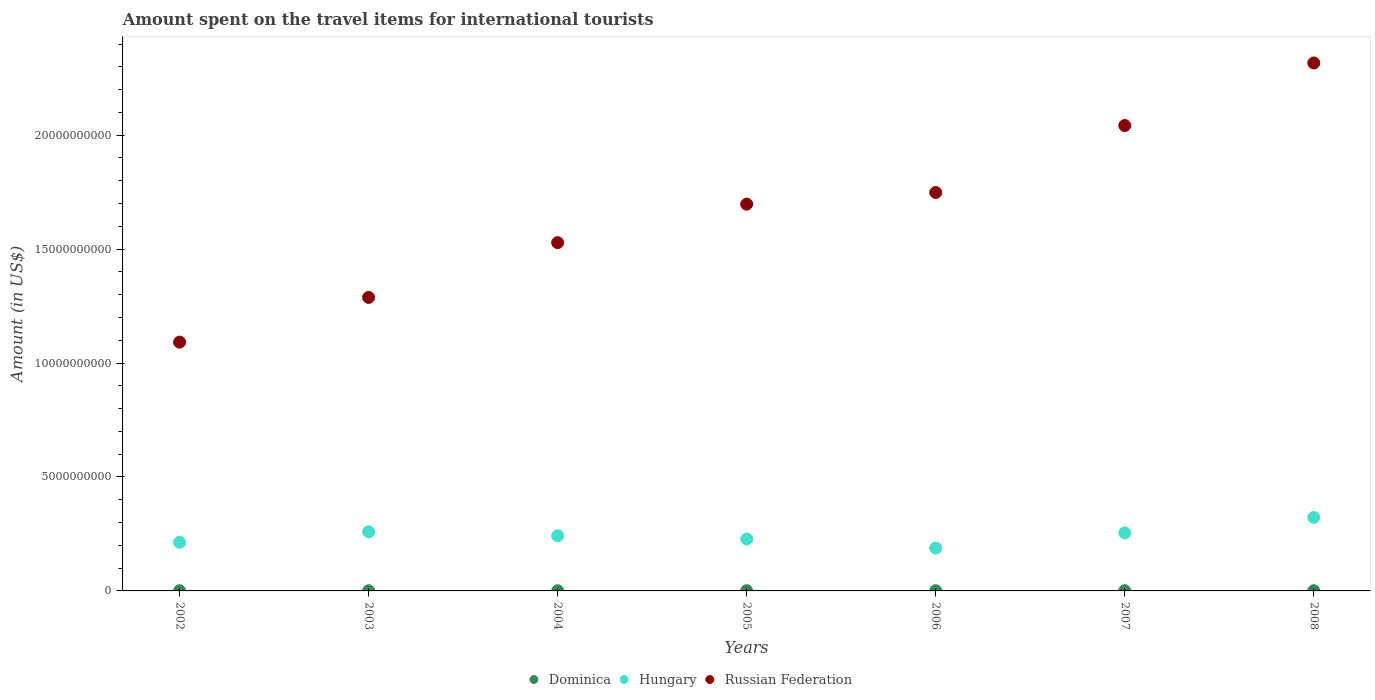Is the number of dotlines equal to the number of legend labels?
Provide a succinct answer. Yes. What is the amount spent on the travel items for international tourists in Hungary in 2006?
Make the answer very short. 1.88e+09. Across all years, what is the maximum amount spent on the travel items for international tourists in Russian Federation?
Give a very brief answer. 2.32e+1. Across all years, what is the minimum amount spent on the travel items for international tourists in Russian Federation?
Give a very brief answer. 1.09e+1. In which year was the amount spent on the travel items for international tourists in Russian Federation maximum?
Ensure brevity in your answer.  2008. What is the total amount spent on the travel items for international tourists in Russian Federation in the graph?
Your answer should be very brief. 1.17e+11. What is the difference between the amount spent on the travel items for international tourists in Russian Federation in 2003 and that in 2008?
Your response must be concise. -1.03e+1. What is the difference between the amount spent on the travel items for international tourists in Russian Federation in 2007 and the amount spent on the travel items for international tourists in Dominica in 2008?
Provide a succinct answer. 2.04e+1. What is the average amount spent on the travel items for international tourists in Dominica per year?
Give a very brief answer. 9.86e+06. In the year 2002, what is the difference between the amount spent on the travel items for international tourists in Hungary and amount spent on the travel items for international tourists in Russian Federation?
Give a very brief answer. -8.78e+09. What is the ratio of the amount spent on the travel items for international tourists in Russian Federation in 2002 to that in 2007?
Give a very brief answer. 0.53. Is the difference between the amount spent on the travel items for international tourists in Hungary in 2003 and 2005 greater than the difference between the amount spent on the travel items for international tourists in Russian Federation in 2003 and 2005?
Your answer should be compact. Yes. What is the difference between the highest and the second highest amount spent on the travel items for international tourists in Russian Federation?
Offer a very short reply. 2.74e+09. What is the difference between the highest and the lowest amount spent on the travel items for international tourists in Russian Federation?
Your answer should be compact. 1.23e+1. In how many years, is the amount spent on the travel items for international tourists in Russian Federation greater than the average amount spent on the travel items for international tourists in Russian Federation taken over all years?
Provide a short and direct response. 4. Is it the case that in every year, the sum of the amount spent on the travel items for international tourists in Russian Federation and amount spent on the travel items for international tourists in Dominica  is greater than the amount spent on the travel items for international tourists in Hungary?
Give a very brief answer. Yes. Is the amount spent on the travel items for international tourists in Hungary strictly greater than the amount spent on the travel items for international tourists in Dominica over the years?
Keep it short and to the point. Yes. How many dotlines are there?
Ensure brevity in your answer.  3. How many years are there in the graph?
Your answer should be compact. 7. Are the values on the major ticks of Y-axis written in scientific E-notation?
Your answer should be very brief. No. What is the title of the graph?
Provide a succinct answer. Amount spent on the travel items for international tourists. What is the label or title of the X-axis?
Provide a succinct answer. Years. What is the Amount (in US$) of Dominica in 2002?
Offer a terse response. 9.00e+06. What is the Amount (in US$) in Hungary in 2002?
Offer a very short reply. 2.13e+09. What is the Amount (in US$) in Russian Federation in 2002?
Give a very brief answer. 1.09e+1. What is the Amount (in US$) in Dominica in 2003?
Provide a succinct answer. 9.00e+06. What is the Amount (in US$) of Hungary in 2003?
Offer a very short reply. 2.59e+09. What is the Amount (in US$) in Russian Federation in 2003?
Offer a very short reply. 1.29e+1. What is the Amount (in US$) of Dominica in 2004?
Ensure brevity in your answer.  9.00e+06. What is the Amount (in US$) in Hungary in 2004?
Provide a succinct answer. 2.42e+09. What is the Amount (in US$) of Russian Federation in 2004?
Make the answer very short. 1.53e+1. What is the Amount (in US$) in Dominica in 2005?
Give a very brief answer. 1.00e+07. What is the Amount (in US$) of Hungary in 2005?
Provide a succinct answer. 2.28e+09. What is the Amount (in US$) in Russian Federation in 2005?
Your answer should be compact. 1.70e+1. What is the Amount (in US$) in Hungary in 2006?
Give a very brief answer. 1.88e+09. What is the Amount (in US$) of Russian Federation in 2006?
Offer a terse response. 1.75e+1. What is the Amount (in US$) in Dominica in 2007?
Keep it short and to the point. 1.10e+07. What is the Amount (in US$) in Hungary in 2007?
Make the answer very short. 2.55e+09. What is the Amount (in US$) of Russian Federation in 2007?
Make the answer very short. 2.04e+1. What is the Amount (in US$) in Dominica in 2008?
Provide a succinct answer. 1.10e+07. What is the Amount (in US$) in Hungary in 2008?
Offer a terse response. 3.22e+09. What is the Amount (in US$) in Russian Federation in 2008?
Ensure brevity in your answer.  2.32e+1. Across all years, what is the maximum Amount (in US$) of Dominica?
Provide a succinct answer. 1.10e+07. Across all years, what is the maximum Amount (in US$) in Hungary?
Provide a succinct answer. 3.22e+09. Across all years, what is the maximum Amount (in US$) in Russian Federation?
Provide a succinct answer. 2.32e+1. Across all years, what is the minimum Amount (in US$) of Dominica?
Your answer should be compact. 9.00e+06. Across all years, what is the minimum Amount (in US$) in Hungary?
Give a very brief answer. 1.88e+09. Across all years, what is the minimum Amount (in US$) of Russian Federation?
Offer a terse response. 1.09e+1. What is the total Amount (in US$) of Dominica in the graph?
Your answer should be very brief. 6.90e+07. What is the total Amount (in US$) of Hungary in the graph?
Offer a terse response. 1.71e+1. What is the total Amount (in US$) of Russian Federation in the graph?
Make the answer very short. 1.17e+11. What is the difference between the Amount (in US$) in Dominica in 2002 and that in 2003?
Your answer should be very brief. 0. What is the difference between the Amount (in US$) of Hungary in 2002 and that in 2003?
Your answer should be compact. -4.61e+08. What is the difference between the Amount (in US$) in Russian Federation in 2002 and that in 2003?
Your response must be concise. -1.96e+09. What is the difference between the Amount (in US$) of Dominica in 2002 and that in 2004?
Offer a very short reply. 0. What is the difference between the Amount (in US$) in Hungary in 2002 and that in 2004?
Give a very brief answer. -2.88e+08. What is the difference between the Amount (in US$) in Russian Federation in 2002 and that in 2004?
Your response must be concise. -4.37e+09. What is the difference between the Amount (in US$) of Dominica in 2002 and that in 2005?
Ensure brevity in your answer.  -1.00e+06. What is the difference between the Amount (in US$) in Hungary in 2002 and that in 2005?
Ensure brevity in your answer.  -1.44e+08. What is the difference between the Amount (in US$) in Russian Federation in 2002 and that in 2005?
Ensure brevity in your answer.  -6.05e+09. What is the difference between the Amount (in US$) in Hungary in 2002 and that in 2006?
Your response must be concise. 2.54e+08. What is the difference between the Amount (in US$) in Russian Federation in 2002 and that in 2006?
Your answer should be very brief. -6.57e+09. What is the difference between the Amount (in US$) of Dominica in 2002 and that in 2007?
Provide a short and direct response. -2.00e+06. What is the difference between the Amount (in US$) of Hungary in 2002 and that in 2007?
Your answer should be compact. -4.13e+08. What is the difference between the Amount (in US$) in Russian Federation in 2002 and that in 2007?
Your answer should be compact. -9.51e+09. What is the difference between the Amount (in US$) in Dominica in 2002 and that in 2008?
Ensure brevity in your answer.  -2.00e+06. What is the difference between the Amount (in US$) in Hungary in 2002 and that in 2008?
Ensure brevity in your answer.  -1.09e+09. What is the difference between the Amount (in US$) in Russian Federation in 2002 and that in 2008?
Provide a short and direct response. -1.23e+1. What is the difference between the Amount (in US$) of Dominica in 2003 and that in 2004?
Offer a terse response. 0. What is the difference between the Amount (in US$) in Hungary in 2003 and that in 2004?
Your answer should be compact. 1.73e+08. What is the difference between the Amount (in US$) of Russian Federation in 2003 and that in 2004?
Offer a terse response. -2.40e+09. What is the difference between the Amount (in US$) of Dominica in 2003 and that in 2005?
Keep it short and to the point. -1.00e+06. What is the difference between the Amount (in US$) of Hungary in 2003 and that in 2005?
Offer a terse response. 3.17e+08. What is the difference between the Amount (in US$) in Russian Federation in 2003 and that in 2005?
Ensure brevity in your answer.  -4.09e+09. What is the difference between the Amount (in US$) of Dominica in 2003 and that in 2006?
Offer a very short reply. -1.00e+06. What is the difference between the Amount (in US$) of Hungary in 2003 and that in 2006?
Your response must be concise. 7.15e+08. What is the difference between the Amount (in US$) in Russian Federation in 2003 and that in 2006?
Your response must be concise. -4.60e+09. What is the difference between the Amount (in US$) of Dominica in 2003 and that in 2007?
Offer a terse response. -2.00e+06. What is the difference between the Amount (in US$) in Hungary in 2003 and that in 2007?
Offer a terse response. 4.80e+07. What is the difference between the Amount (in US$) in Russian Federation in 2003 and that in 2007?
Your response must be concise. -7.54e+09. What is the difference between the Amount (in US$) in Hungary in 2003 and that in 2008?
Offer a terse response. -6.31e+08. What is the difference between the Amount (in US$) of Russian Federation in 2003 and that in 2008?
Your answer should be compact. -1.03e+1. What is the difference between the Amount (in US$) of Dominica in 2004 and that in 2005?
Your answer should be compact. -1.00e+06. What is the difference between the Amount (in US$) in Hungary in 2004 and that in 2005?
Your answer should be very brief. 1.44e+08. What is the difference between the Amount (in US$) of Russian Federation in 2004 and that in 2005?
Keep it short and to the point. -1.69e+09. What is the difference between the Amount (in US$) of Hungary in 2004 and that in 2006?
Give a very brief answer. 5.42e+08. What is the difference between the Amount (in US$) of Russian Federation in 2004 and that in 2006?
Your response must be concise. -2.20e+09. What is the difference between the Amount (in US$) in Hungary in 2004 and that in 2007?
Give a very brief answer. -1.25e+08. What is the difference between the Amount (in US$) of Russian Federation in 2004 and that in 2007?
Offer a terse response. -5.14e+09. What is the difference between the Amount (in US$) in Dominica in 2004 and that in 2008?
Make the answer very short. -2.00e+06. What is the difference between the Amount (in US$) of Hungary in 2004 and that in 2008?
Ensure brevity in your answer.  -8.04e+08. What is the difference between the Amount (in US$) in Russian Federation in 2004 and that in 2008?
Offer a terse response. -7.88e+09. What is the difference between the Amount (in US$) of Dominica in 2005 and that in 2006?
Offer a terse response. 0. What is the difference between the Amount (in US$) in Hungary in 2005 and that in 2006?
Keep it short and to the point. 3.98e+08. What is the difference between the Amount (in US$) in Russian Federation in 2005 and that in 2006?
Your response must be concise. -5.12e+08. What is the difference between the Amount (in US$) in Dominica in 2005 and that in 2007?
Your answer should be compact. -1.00e+06. What is the difference between the Amount (in US$) in Hungary in 2005 and that in 2007?
Your answer should be compact. -2.69e+08. What is the difference between the Amount (in US$) in Russian Federation in 2005 and that in 2007?
Give a very brief answer. -3.45e+09. What is the difference between the Amount (in US$) in Hungary in 2005 and that in 2008?
Your answer should be compact. -9.48e+08. What is the difference between the Amount (in US$) of Russian Federation in 2005 and that in 2008?
Your response must be concise. -6.20e+09. What is the difference between the Amount (in US$) of Dominica in 2006 and that in 2007?
Give a very brief answer. -1.00e+06. What is the difference between the Amount (in US$) of Hungary in 2006 and that in 2007?
Provide a succinct answer. -6.67e+08. What is the difference between the Amount (in US$) of Russian Federation in 2006 and that in 2007?
Offer a terse response. -2.94e+09. What is the difference between the Amount (in US$) of Dominica in 2006 and that in 2008?
Your answer should be compact. -1.00e+06. What is the difference between the Amount (in US$) of Hungary in 2006 and that in 2008?
Offer a very short reply. -1.35e+09. What is the difference between the Amount (in US$) in Russian Federation in 2006 and that in 2008?
Give a very brief answer. -5.68e+09. What is the difference between the Amount (in US$) of Dominica in 2007 and that in 2008?
Give a very brief answer. 0. What is the difference between the Amount (in US$) of Hungary in 2007 and that in 2008?
Your answer should be very brief. -6.79e+08. What is the difference between the Amount (in US$) in Russian Federation in 2007 and that in 2008?
Ensure brevity in your answer.  -2.74e+09. What is the difference between the Amount (in US$) of Dominica in 2002 and the Amount (in US$) of Hungary in 2003?
Give a very brief answer. -2.58e+09. What is the difference between the Amount (in US$) of Dominica in 2002 and the Amount (in US$) of Russian Federation in 2003?
Make the answer very short. -1.29e+1. What is the difference between the Amount (in US$) of Hungary in 2002 and the Amount (in US$) of Russian Federation in 2003?
Keep it short and to the point. -1.07e+1. What is the difference between the Amount (in US$) of Dominica in 2002 and the Amount (in US$) of Hungary in 2004?
Your response must be concise. -2.41e+09. What is the difference between the Amount (in US$) of Dominica in 2002 and the Amount (in US$) of Russian Federation in 2004?
Your answer should be very brief. -1.53e+1. What is the difference between the Amount (in US$) in Hungary in 2002 and the Amount (in US$) in Russian Federation in 2004?
Your response must be concise. -1.32e+1. What is the difference between the Amount (in US$) of Dominica in 2002 and the Amount (in US$) of Hungary in 2005?
Provide a succinct answer. -2.27e+09. What is the difference between the Amount (in US$) in Dominica in 2002 and the Amount (in US$) in Russian Federation in 2005?
Give a very brief answer. -1.70e+1. What is the difference between the Amount (in US$) in Hungary in 2002 and the Amount (in US$) in Russian Federation in 2005?
Your answer should be compact. -1.48e+1. What is the difference between the Amount (in US$) in Dominica in 2002 and the Amount (in US$) in Hungary in 2006?
Keep it short and to the point. -1.87e+09. What is the difference between the Amount (in US$) in Dominica in 2002 and the Amount (in US$) in Russian Federation in 2006?
Your answer should be compact. -1.75e+1. What is the difference between the Amount (in US$) in Hungary in 2002 and the Amount (in US$) in Russian Federation in 2006?
Your response must be concise. -1.54e+1. What is the difference between the Amount (in US$) of Dominica in 2002 and the Amount (in US$) of Hungary in 2007?
Provide a short and direct response. -2.54e+09. What is the difference between the Amount (in US$) of Dominica in 2002 and the Amount (in US$) of Russian Federation in 2007?
Provide a short and direct response. -2.04e+1. What is the difference between the Amount (in US$) in Hungary in 2002 and the Amount (in US$) in Russian Federation in 2007?
Provide a short and direct response. -1.83e+1. What is the difference between the Amount (in US$) in Dominica in 2002 and the Amount (in US$) in Hungary in 2008?
Keep it short and to the point. -3.22e+09. What is the difference between the Amount (in US$) of Dominica in 2002 and the Amount (in US$) of Russian Federation in 2008?
Give a very brief answer. -2.32e+1. What is the difference between the Amount (in US$) in Hungary in 2002 and the Amount (in US$) in Russian Federation in 2008?
Keep it short and to the point. -2.10e+1. What is the difference between the Amount (in US$) in Dominica in 2003 and the Amount (in US$) in Hungary in 2004?
Your answer should be compact. -2.41e+09. What is the difference between the Amount (in US$) in Dominica in 2003 and the Amount (in US$) in Russian Federation in 2004?
Your answer should be very brief. -1.53e+1. What is the difference between the Amount (in US$) of Hungary in 2003 and the Amount (in US$) of Russian Federation in 2004?
Your answer should be compact. -1.27e+1. What is the difference between the Amount (in US$) of Dominica in 2003 and the Amount (in US$) of Hungary in 2005?
Your response must be concise. -2.27e+09. What is the difference between the Amount (in US$) of Dominica in 2003 and the Amount (in US$) of Russian Federation in 2005?
Provide a succinct answer. -1.70e+1. What is the difference between the Amount (in US$) of Hungary in 2003 and the Amount (in US$) of Russian Federation in 2005?
Give a very brief answer. -1.44e+1. What is the difference between the Amount (in US$) of Dominica in 2003 and the Amount (in US$) of Hungary in 2006?
Provide a short and direct response. -1.87e+09. What is the difference between the Amount (in US$) of Dominica in 2003 and the Amount (in US$) of Russian Federation in 2006?
Give a very brief answer. -1.75e+1. What is the difference between the Amount (in US$) in Hungary in 2003 and the Amount (in US$) in Russian Federation in 2006?
Give a very brief answer. -1.49e+1. What is the difference between the Amount (in US$) of Dominica in 2003 and the Amount (in US$) of Hungary in 2007?
Ensure brevity in your answer.  -2.54e+09. What is the difference between the Amount (in US$) in Dominica in 2003 and the Amount (in US$) in Russian Federation in 2007?
Give a very brief answer. -2.04e+1. What is the difference between the Amount (in US$) of Hungary in 2003 and the Amount (in US$) of Russian Federation in 2007?
Provide a succinct answer. -1.78e+1. What is the difference between the Amount (in US$) of Dominica in 2003 and the Amount (in US$) of Hungary in 2008?
Your answer should be compact. -3.22e+09. What is the difference between the Amount (in US$) in Dominica in 2003 and the Amount (in US$) in Russian Federation in 2008?
Keep it short and to the point. -2.32e+1. What is the difference between the Amount (in US$) of Hungary in 2003 and the Amount (in US$) of Russian Federation in 2008?
Ensure brevity in your answer.  -2.06e+1. What is the difference between the Amount (in US$) in Dominica in 2004 and the Amount (in US$) in Hungary in 2005?
Offer a terse response. -2.27e+09. What is the difference between the Amount (in US$) of Dominica in 2004 and the Amount (in US$) of Russian Federation in 2005?
Your answer should be very brief. -1.70e+1. What is the difference between the Amount (in US$) of Hungary in 2004 and the Amount (in US$) of Russian Federation in 2005?
Provide a short and direct response. -1.46e+1. What is the difference between the Amount (in US$) in Dominica in 2004 and the Amount (in US$) in Hungary in 2006?
Provide a short and direct response. -1.87e+09. What is the difference between the Amount (in US$) of Dominica in 2004 and the Amount (in US$) of Russian Federation in 2006?
Offer a very short reply. -1.75e+1. What is the difference between the Amount (in US$) of Hungary in 2004 and the Amount (in US$) of Russian Federation in 2006?
Offer a very short reply. -1.51e+1. What is the difference between the Amount (in US$) in Dominica in 2004 and the Amount (in US$) in Hungary in 2007?
Offer a terse response. -2.54e+09. What is the difference between the Amount (in US$) of Dominica in 2004 and the Amount (in US$) of Russian Federation in 2007?
Your answer should be compact. -2.04e+1. What is the difference between the Amount (in US$) of Hungary in 2004 and the Amount (in US$) of Russian Federation in 2007?
Your answer should be very brief. -1.80e+1. What is the difference between the Amount (in US$) of Dominica in 2004 and the Amount (in US$) of Hungary in 2008?
Your answer should be compact. -3.22e+09. What is the difference between the Amount (in US$) in Dominica in 2004 and the Amount (in US$) in Russian Federation in 2008?
Ensure brevity in your answer.  -2.32e+1. What is the difference between the Amount (in US$) in Hungary in 2004 and the Amount (in US$) in Russian Federation in 2008?
Ensure brevity in your answer.  -2.07e+1. What is the difference between the Amount (in US$) in Dominica in 2005 and the Amount (in US$) in Hungary in 2006?
Your answer should be compact. -1.87e+09. What is the difference between the Amount (in US$) of Dominica in 2005 and the Amount (in US$) of Russian Federation in 2006?
Your answer should be compact. -1.75e+1. What is the difference between the Amount (in US$) in Hungary in 2005 and the Amount (in US$) in Russian Federation in 2006?
Your answer should be compact. -1.52e+1. What is the difference between the Amount (in US$) of Dominica in 2005 and the Amount (in US$) of Hungary in 2007?
Your response must be concise. -2.54e+09. What is the difference between the Amount (in US$) of Dominica in 2005 and the Amount (in US$) of Russian Federation in 2007?
Keep it short and to the point. -2.04e+1. What is the difference between the Amount (in US$) of Hungary in 2005 and the Amount (in US$) of Russian Federation in 2007?
Provide a succinct answer. -1.81e+1. What is the difference between the Amount (in US$) of Dominica in 2005 and the Amount (in US$) of Hungary in 2008?
Offer a very short reply. -3.22e+09. What is the difference between the Amount (in US$) of Dominica in 2005 and the Amount (in US$) of Russian Federation in 2008?
Ensure brevity in your answer.  -2.32e+1. What is the difference between the Amount (in US$) in Hungary in 2005 and the Amount (in US$) in Russian Federation in 2008?
Give a very brief answer. -2.09e+1. What is the difference between the Amount (in US$) in Dominica in 2006 and the Amount (in US$) in Hungary in 2007?
Your response must be concise. -2.54e+09. What is the difference between the Amount (in US$) in Dominica in 2006 and the Amount (in US$) in Russian Federation in 2007?
Your response must be concise. -2.04e+1. What is the difference between the Amount (in US$) in Hungary in 2006 and the Amount (in US$) in Russian Federation in 2007?
Your answer should be compact. -1.85e+1. What is the difference between the Amount (in US$) in Dominica in 2006 and the Amount (in US$) in Hungary in 2008?
Offer a terse response. -3.22e+09. What is the difference between the Amount (in US$) of Dominica in 2006 and the Amount (in US$) of Russian Federation in 2008?
Your response must be concise. -2.32e+1. What is the difference between the Amount (in US$) in Hungary in 2006 and the Amount (in US$) in Russian Federation in 2008?
Your answer should be very brief. -2.13e+1. What is the difference between the Amount (in US$) in Dominica in 2007 and the Amount (in US$) in Hungary in 2008?
Provide a short and direct response. -3.21e+09. What is the difference between the Amount (in US$) in Dominica in 2007 and the Amount (in US$) in Russian Federation in 2008?
Provide a short and direct response. -2.32e+1. What is the difference between the Amount (in US$) in Hungary in 2007 and the Amount (in US$) in Russian Federation in 2008?
Offer a very short reply. -2.06e+1. What is the average Amount (in US$) in Dominica per year?
Make the answer very short. 9.86e+06. What is the average Amount (in US$) in Hungary per year?
Ensure brevity in your answer.  2.44e+09. What is the average Amount (in US$) of Russian Federation per year?
Ensure brevity in your answer.  1.67e+1. In the year 2002, what is the difference between the Amount (in US$) of Dominica and Amount (in US$) of Hungary?
Your answer should be compact. -2.12e+09. In the year 2002, what is the difference between the Amount (in US$) of Dominica and Amount (in US$) of Russian Federation?
Your response must be concise. -1.09e+1. In the year 2002, what is the difference between the Amount (in US$) of Hungary and Amount (in US$) of Russian Federation?
Your response must be concise. -8.78e+09. In the year 2003, what is the difference between the Amount (in US$) of Dominica and Amount (in US$) of Hungary?
Your response must be concise. -2.58e+09. In the year 2003, what is the difference between the Amount (in US$) in Dominica and Amount (in US$) in Russian Federation?
Your answer should be very brief. -1.29e+1. In the year 2003, what is the difference between the Amount (in US$) of Hungary and Amount (in US$) of Russian Federation?
Provide a short and direct response. -1.03e+1. In the year 2004, what is the difference between the Amount (in US$) in Dominica and Amount (in US$) in Hungary?
Your response must be concise. -2.41e+09. In the year 2004, what is the difference between the Amount (in US$) of Dominica and Amount (in US$) of Russian Federation?
Give a very brief answer. -1.53e+1. In the year 2004, what is the difference between the Amount (in US$) in Hungary and Amount (in US$) in Russian Federation?
Make the answer very short. -1.29e+1. In the year 2005, what is the difference between the Amount (in US$) of Dominica and Amount (in US$) of Hungary?
Your answer should be very brief. -2.27e+09. In the year 2005, what is the difference between the Amount (in US$) in Dominica and Amount (in US$) in Russian Federation?
Ensure brevity in your answer.  -1.70e+1. In the year 2005, what is the difference between the Amount (in US$) in Hungary and Amount (in US$) in Russian Federation?
Your answer should be very brief. -1.47e+1. In the year 2006, what is the difference between the Amount (in US$) in Dominica and Amount (in US$) in Hungary?
Give a very brief answer. -1.87e+09. In the year 2006, what is the difference between the Amount (in US$) in Dominica and Amount (in US$) in Russian Federation?
Offer a very short reply. -1.75e+1. In the year 2006, what is the difference between the Amount (in US$) in Hungary and Amount (in US$) in Russian Federation?
Provide a succinct answer. -1.56e+1. In the year 2007, what is the difference between the Amount (in US$) in Dominica and Amount (in US$) in Hungary?
Provide a succinct answer. -2.54e+09. In the year 2007, what is the difference between the Amount (in US$) of Dominica and Amount (in US$) of Russian Federation?
Offer a very short reply. -2.04e+1. In the year 2007, what is the difference between the Amount (in US$) of Hungary and Amount (in US$) of Russian Federation?
Make the answer very short. -1.79e+1. In the year 2008, what is the difference between the Amount (in US$) in Dominica and Amount (in US$) in Hungary?
Your answer should be very brief. -3.21e+09. In the year 2008, what is the difference between the Amount (in US$) in Dominica and Amount (in US$) in Russian Federation?
Provide a succinct answer. -2.32e+1. In the year 2008, what is the difference between the Amount (in US$) in Hungary and Amount (in US$) in Russian Federation?
Ensure brevity in your answer.  -1.99e+1. What is the ratio of the Amount (in US$) of Dominica in 2002 to that in 2003?
Offer a very short reply. 1. What is the ratio of the Amount (in US$) in Hungary in 2002 to that in 2003?
Your answer should be very brief. 0.82. What is the ratio of the Amount (in US$) of Russian Federation in 2002 to that in 2003?
Offer a very short reply. 0.85. What is the ratio of the Amount (in US$) in Hungary in 2002 to that in 2004?
Ensure brevity in your answer.  0.88. What is the ratio of the Amount (in US$) of Russian Federation in 2002 to that in 2004?
Provide a succinct answer. 0.71. What is the ratio of the Amount (in US$) of Dominica in 2002 to that in 2005?
Provide a short and direct response. 0.9. What is the ratio of the Amount (in US$) in Hungary in 2002 to that in 2005?
Your response must be concise. 0.94. What is the ratio of the Amount (in US$) in Russian Federation in 2002 to that in 2005?
Provide a short and direct response. 0.64. What is the ratio of the Amount (in US$) of Hungary in 2002 to that in 2006?
Your answer should be very brief. 1.14. What is the ratio of the Amount (in US$) of Russian Federation in 2002 to that in 2006?
Offer a terse response. 0.62. What is the ratio of the Amount (in US$) in Dominica in 2002 to that in 2007?
Your response must be concise. 0.82. What is the ratio of the Amount (in US$) in Hungary in 2002 to that in 2007?
Offer a terse response. 0.84. What is the ratio of the Amount (in US$) in Russian Federation in 2002 to that in 2007?
Provide a short and direct response. 0.53. What is the ratio of the Amount (in US$) in Dominica in 2002 to that in 2008?
Make the answer very short. 0.82. What is the ratio of the Amount (in US$) in Hungary in 2002 to that in 2008?
Ensure brevity in your answer.  0.66. What is the ratio of the Amount (in US$) of Russian Federation in 2002 to that in 2008?
Offer a very short reply. 0.47. What is the ratio of the Amount (in US$) in Hungary in 2003 to that in 2004?
Your response must be concise. 1.07. What is the ratio of the Amount (in US$) of Russian Federation in 2003 to that in 2004?
Offer a very short reply. 0.84. What is the ratio of the Amount (in US$) of Hungary in 2003 to that in 2005?
Your response must be concise. 1.14. What is the ratio of the Amount (in US$) of Russian Federation in 2003 to that in 2005?
Ensure brevity in your answer.  0.76. What is the ratio of the Amount (in US$) in Dominica in 2003 to that in 2006?
Keep it short and to the point. 0.9. What is the ratio of the Amount (in US$) of Hungary in 2003 to that in 2006?
Offer a very short reply. 1.38. What is the ratio of the Amount (in US$) in Russian Federation in 2003 to that in 2006?
Provide a succinct answer. 0.74. What is the ratio of the Amount (in US$) in Dominica in 2003 to that in 2007?
Your response must be concise. 0.82. What is the ratio of the Amount (in US$) of Hungary in 2003 to that in 2007?
Offer a very short reply. 1.02. What is the ratio of the Amount (in US$) in Russian Federation in 2003 to that in 2007?
Make the answer very short. 0.63. What is the ratio of the Amount (in US$) in Dominica in 2003 to that in 2008?
Ensure brevity in your answer.  0.82. What is the ratio of the Amount (in US$) in Hungary in 2003 to that in 2008?
Offer a very short reply. 0.8. What is the ratio of the Amount (in US$) of Russian Federation in 2003 to that in 2008?
Give a very brief answer. 0.56. What is the ratio of the Amount (in US$) of Dominica in 2004 to that in 2005?
Ensure brevity in your answer.  0.9. What is the ratio of the Amount (in US$) in Hungary in 2004 to that in 2005?
Ensure brevity in your answer.  1.06. What is the ratio of the Amount (in US$) in Russian Federation in 2004 to that in 2005?
Keep it short and to the point. 0.9. What is the ratio of the Amount (in US$) in Hungary in 2004 to that in 2006?
Provide a short and direct response. 1.29. What is the ratio of the Amount (in US$) in Russian Federation in 2004 to that in 2006?
Make the answer very short. 0.87. What is the ratio of the Amount (in US$) in Dominica in 2004 to that in 2007?
Offer a very short reply. 0.82. What is the ratio of the Amount (in US$) in Hungary in 2004 to that in 2007?
Make the answer very short. 0.95. What is the ratio of the Amount (in US$) in Russian Federation in 2004 to that in 2007?
Keep it short and to the point. 0.75. What is the ratio of the Amount (in US$) in Dominica in 2004 to that in 2008?
Give a very brief answer. 0.82. What is the ratio of the Amount (in US$) in Hungary in 2004 to that in 2008?
Ensure brevity in your answer.  0.75. What is the ratio of the Amount (in US$) in Russian Federation in 2004 to that in 2008?
Make the answer very short. 0.66. What is the ratio of the Amount (in US$) in Hungary in 2005 to that in 2006?
Give a very brief answer. 1.21. What is the ratio of the Amount (in US$) in Russian Federation in 2005 to that in 2006?
Provide a succinct answer. 0.97. What is the ratio of the Amount (in US$) in Dominica in 2005 to that in 2007?
Make the answer very short. 0.91. What is the ratio of the Amount (in US$) of Hungary in 2005 to that in 2007?
Offer a terse response. 0.89. What is the ratio of the Amount (in US$) of Russian Federation in 2005 to that in 2007?
Offer a very short reply. 0.83. What is the ratio of the Amount (in US$) in Hungary in 2005 to that in 2008?
Ensure brevity in your answer.  0.71. What is the ratio of the Amount (in US$) of Russian Federation in 2005 to that in 2008?
Your answer should be compact. 0.73. What is the ratio of the Amount (in US$) of Dominica in 2006 to that in 2007?
Make the answer very short. 0.91. What is the ratio of the Amount (in US$) in Hungary in 2006 to that in 2007?
Give a very brief answer. 0.74. What is the ratio of the Amount (in US$) in Russian Federation in 2006 to that in 2007?
Offer a terse response. 0.86. What is the ratio of the Amount (in US$) in Hungary in 2006 to that in 2008?
Provide a succinct answer. 0.58. What is the ratio of the Amount (in US$) in Russian Federation in 2006 to that in 2008?
Your response must be concise. 0.75. What is the ratio of the Amount (in US$) of Dominica in 2007 to that in 2008?
Provide a succinct answer. 1. What is the ratio of the Amount (in US$) in Hungary in 2007 to that in 2008?
Make the answer very short. 0.79. What is the ratio of the Amount (in US$) in Russian Federation in 2007 to that in 2008?
Provide a short and direct response. 0.88. What is the difference between the highest and the second highest Amount (in US$) of Dominica?
Provide a short and direct response. 0. What is the difference between the highest and the second highest Amount (in US$) in Hungary?
Your answer should be very brief. 6.31e+08. What is the difference between the highest and the second highest Amount (in US$) in Russian Federation?
Your answer should be very brief. 2.74e+09. What is the difference between the highest and the lowest Amount (in US$) of Dominica?
Make the answer very short. 2.00e+06. What is the difference between the highest and the lowest Amount (in US$) in Hungary?
Provide a succinct answer. 1.35e+09. What is the difference between the highest and the lowest Amount (in US$) of Russian Federation?
Keep it short and to the point. 1.23e+1. 